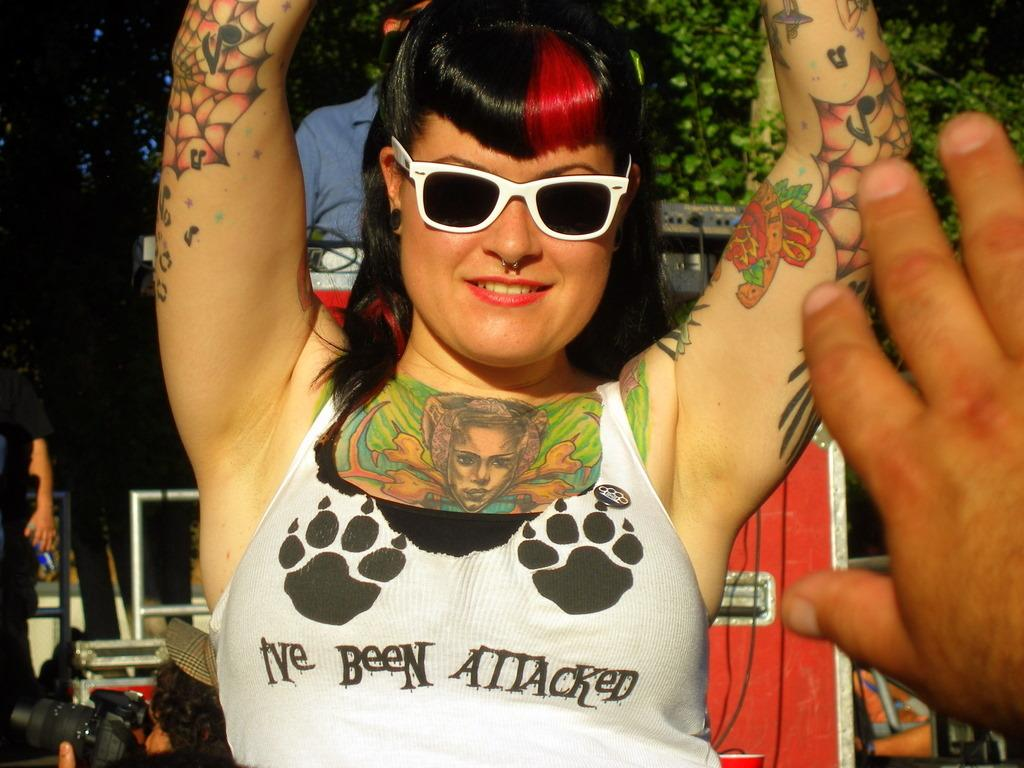What are the people in the image wearing? The people in the image are wearing clothes. Can you describe the accessories worn by the woman in the image? The woman is wearing ear studs, goggles, and a nose ring. What part of the body can be seen in the image? A hand is visible in the image. What type of objects can be seen in the image? There are objects in the image, but their specific nature is not mentioned in the facts. What is the cable wire used for in the image? The facts do not specify the purpose of the cable wire in the image. What type of vegetation is visible in the image? Leaves are visible in the image. What type of mist can be seen surrounding the lake in the image? There is no lake or mist present in the image. What type of apparatus is being used by the people in the image? The facts do not specify any apparatus being used by the people in the image. 